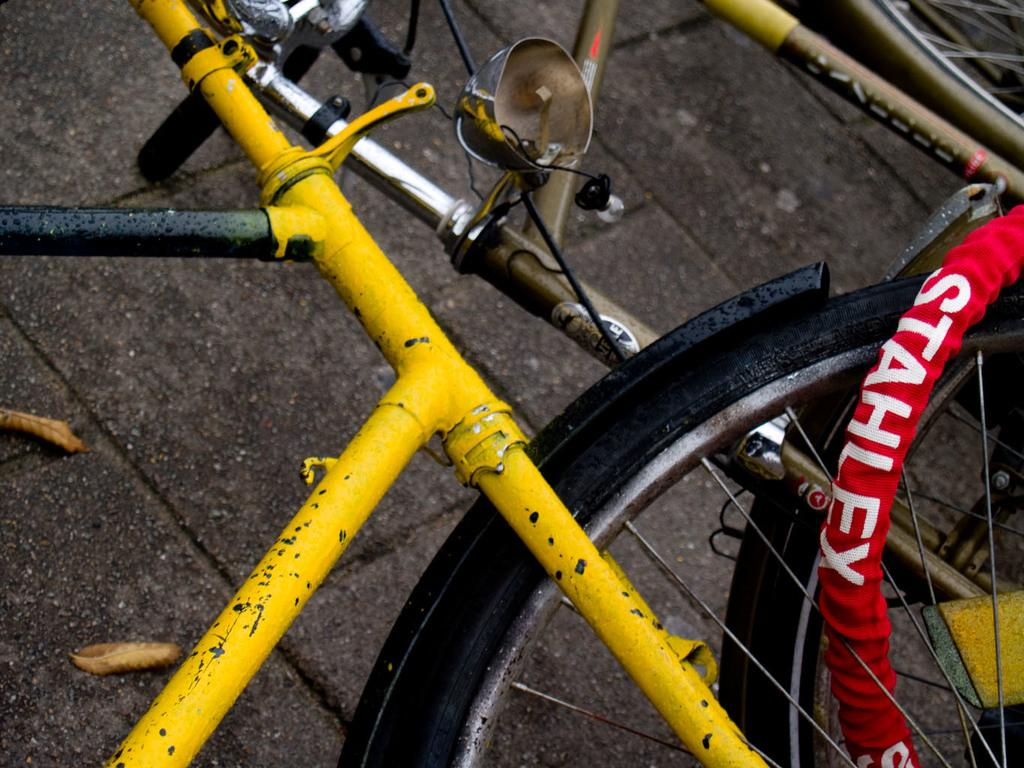What type of vehicles are present in the image? There are bicycles in the image. What can be seen on the ground in the image? There are dry leaves on the floor in the image. What type of grip does the man have on the bicycle in the image? There is no man present in the image, and therefore no grip to describe. 